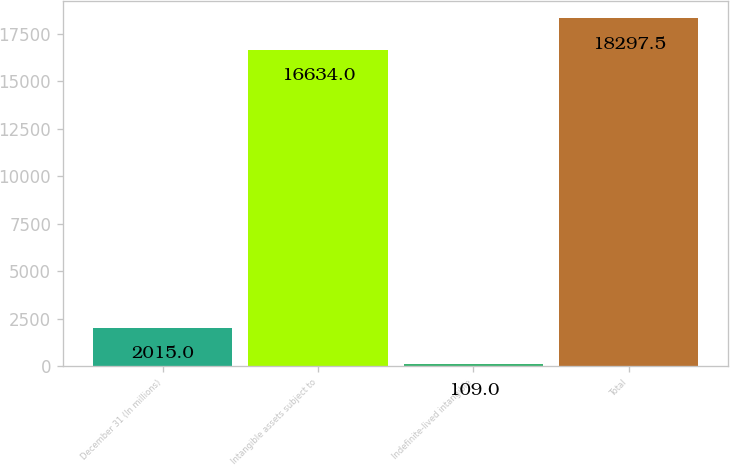Convert chart. <chart><loc_0><loc_0><loc_500><loc_500><bar_chart><fcel>December 31 (In millions)<fcel>Intangible assets subject to<fcel>Indefinite-lived intangible<fcel>Total<nl><fcel>2015<fcel>16634<fcel>109<fcel>18297.5<nl></chart> 